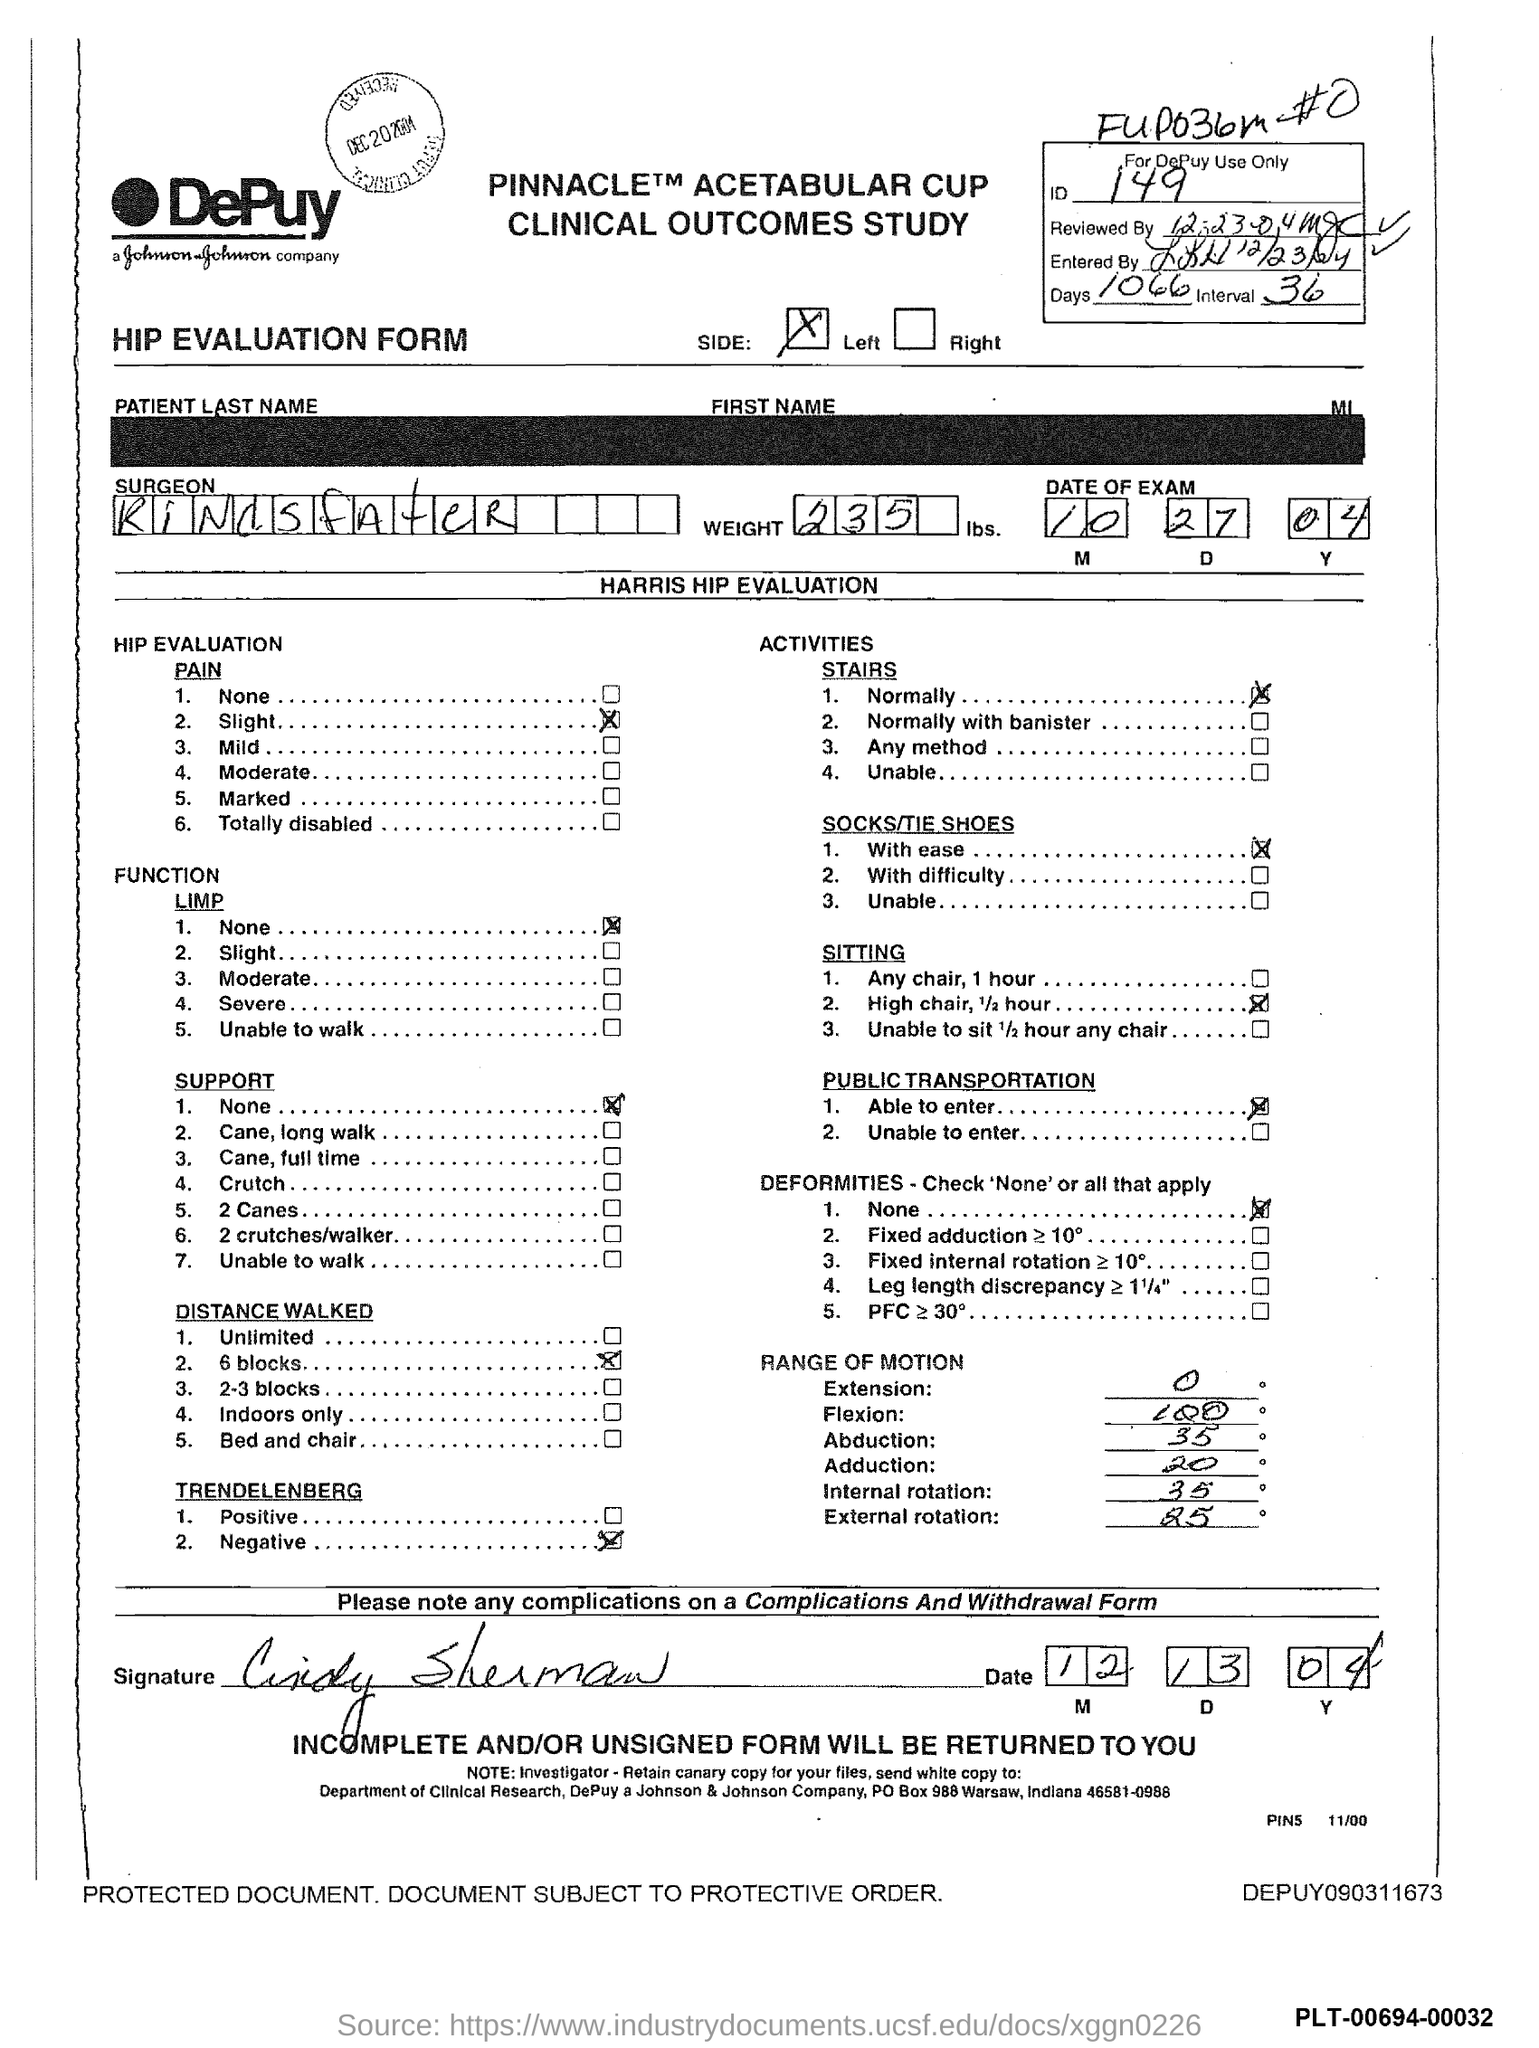Mention a couple of crucial points in this snapshot. What is the ID number?" the man asked, trailing off with a stutter as the number 149 was mentioned. 